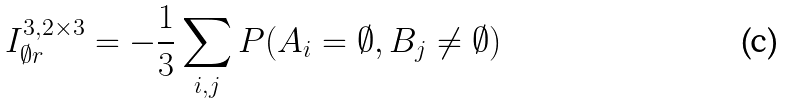<formula> <loc_0><loc_0><loc_500><loc_500>I ^ { 3 , 2 \times 3 } _ { \emptyset r } = - \frac { 1 } { 3 } \sum _ { i , j } P ( A _ { i } = \emptyset , B _ { j } \neq \emptyset )</formula> 